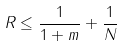Convert formula to latex. <formula><loc_0><loc_0><loc_500><loc_500>R \leq \frac { 1 } { 1 + m } + \frac { 1 } { N }</formula> 